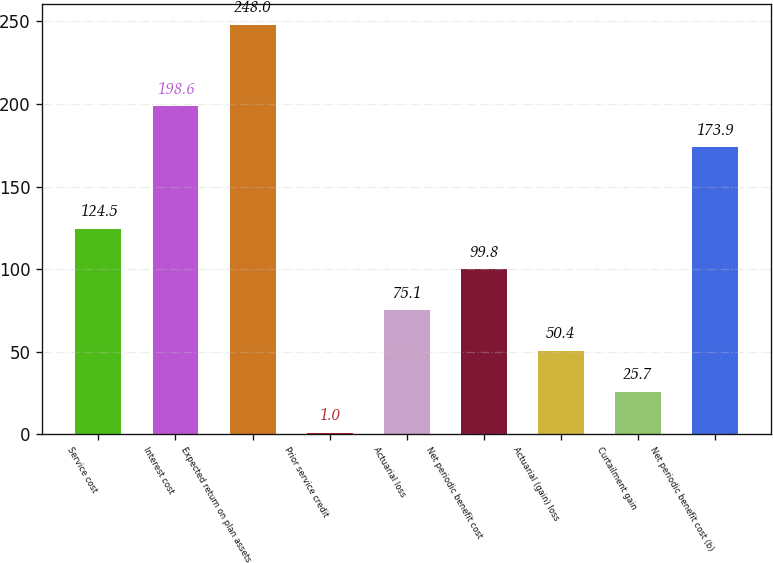<chart> <loc_0><loc_0><loc_500><loc_500><bar_chart><fcel>Service cost<fcel>Interest cost<fcel>Expected return on plan assets<fcel>Prior service credit<fcel>Actuarial loss<fcel>Net periodic benefit cost<fcel>Actuarial (gain) loss<fcel>Curtailment gain<fcel>Net periodic benefit cost (b)<nl><fcel>124.5<fcel>198.6<fcel>248<fcel>1<fcel>75.1<fcel>99.8<fcel>50.4<fcel>25.7<fcel>173.9<nl></chart> 